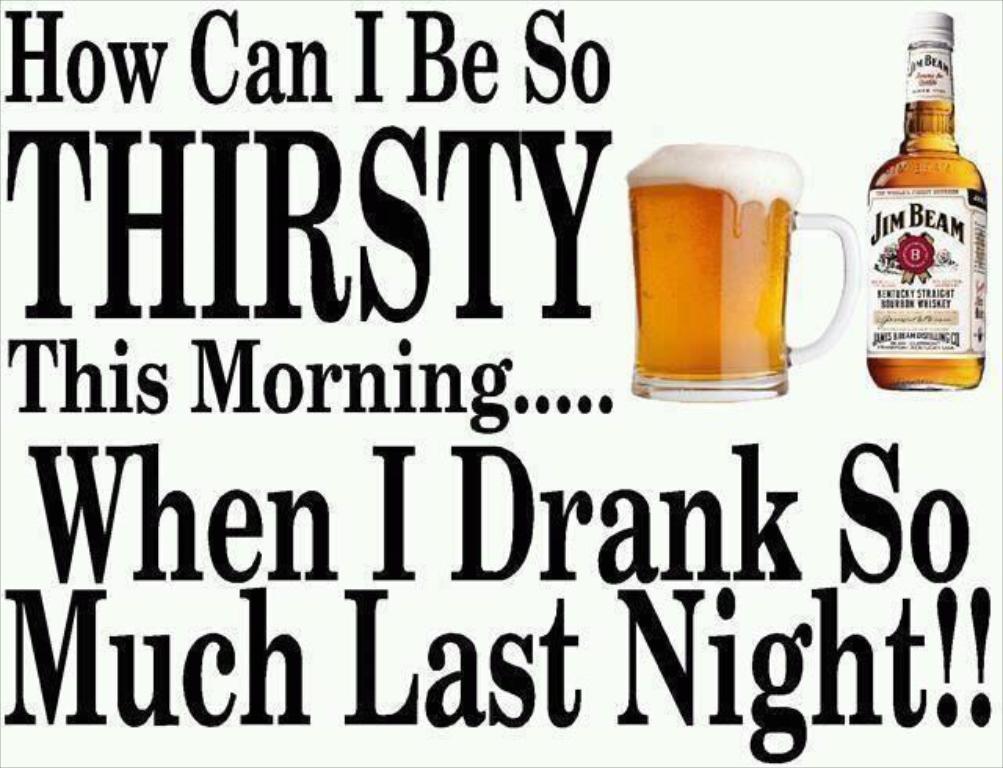What is the name of teh liquor?
Provide a succinct answer. Jim beam. 